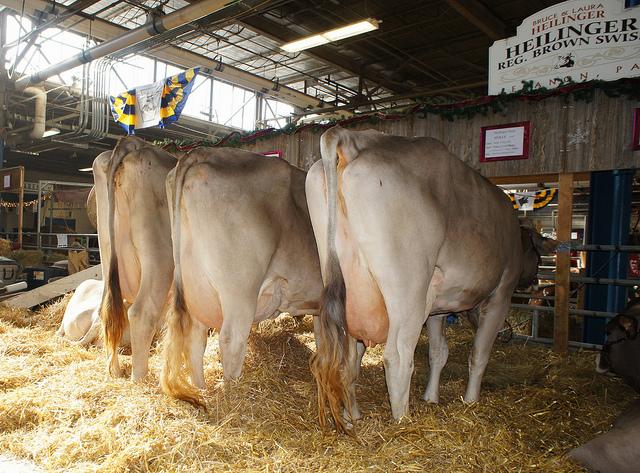Are the cows currently being milked?
Answer briefly. No. What color are the animals?
Short answer required. White. How many cows are in the picture?
Keep it brief. 4. 